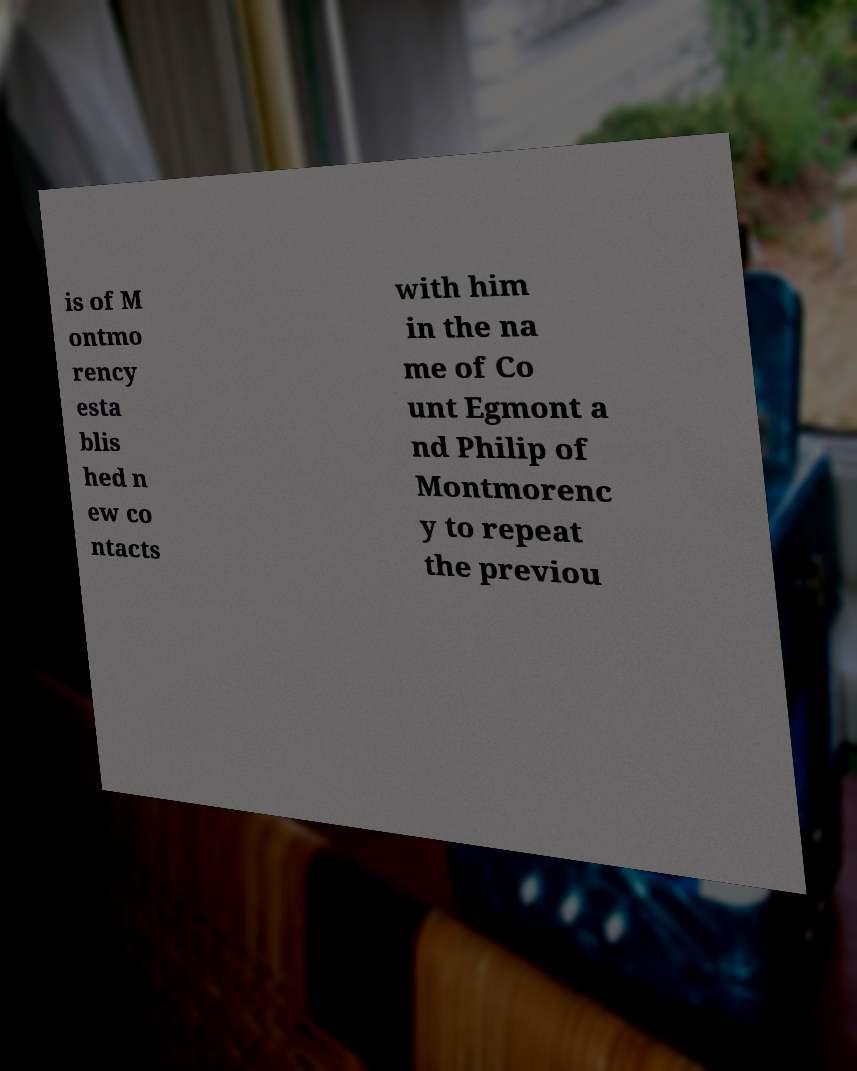Please read and relay the text visible in this image. What does it say? is of M ontmo rency esta blis hed n ew co ntacts with him in the na me of Co unt Egmont a nd Philip of Montmorenc y to repeat the previou 